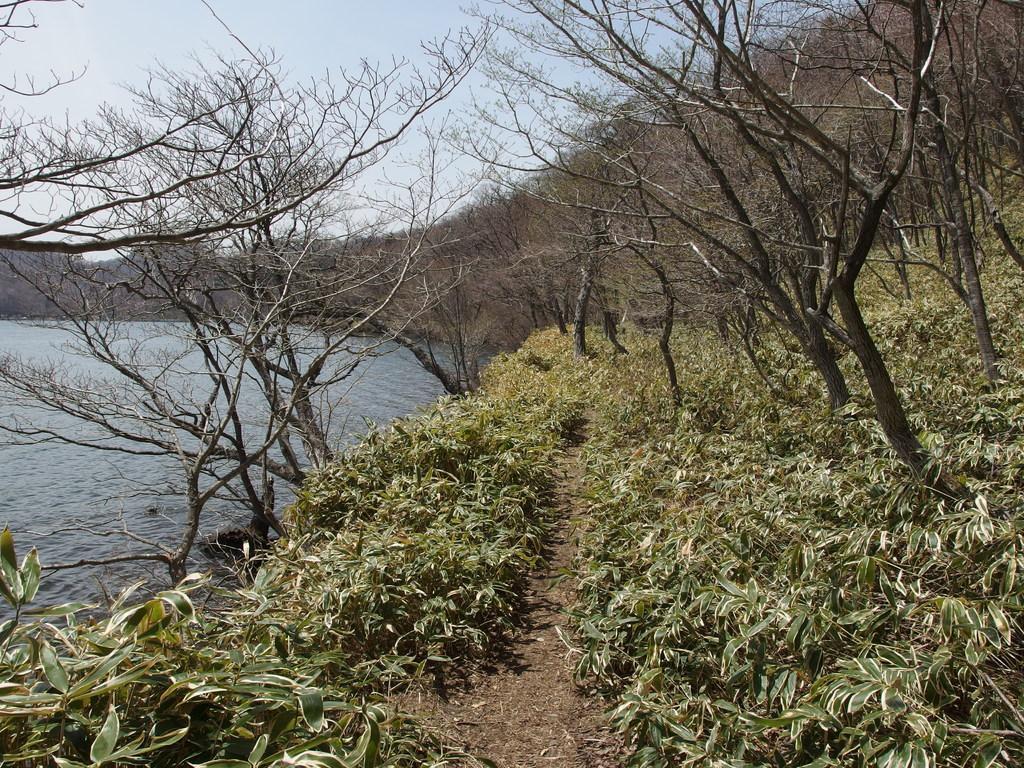Could you give a brief overview of what you see in this image? There is a way and there are few plants and dried trees on either sides of it and there is water in the left corner. 